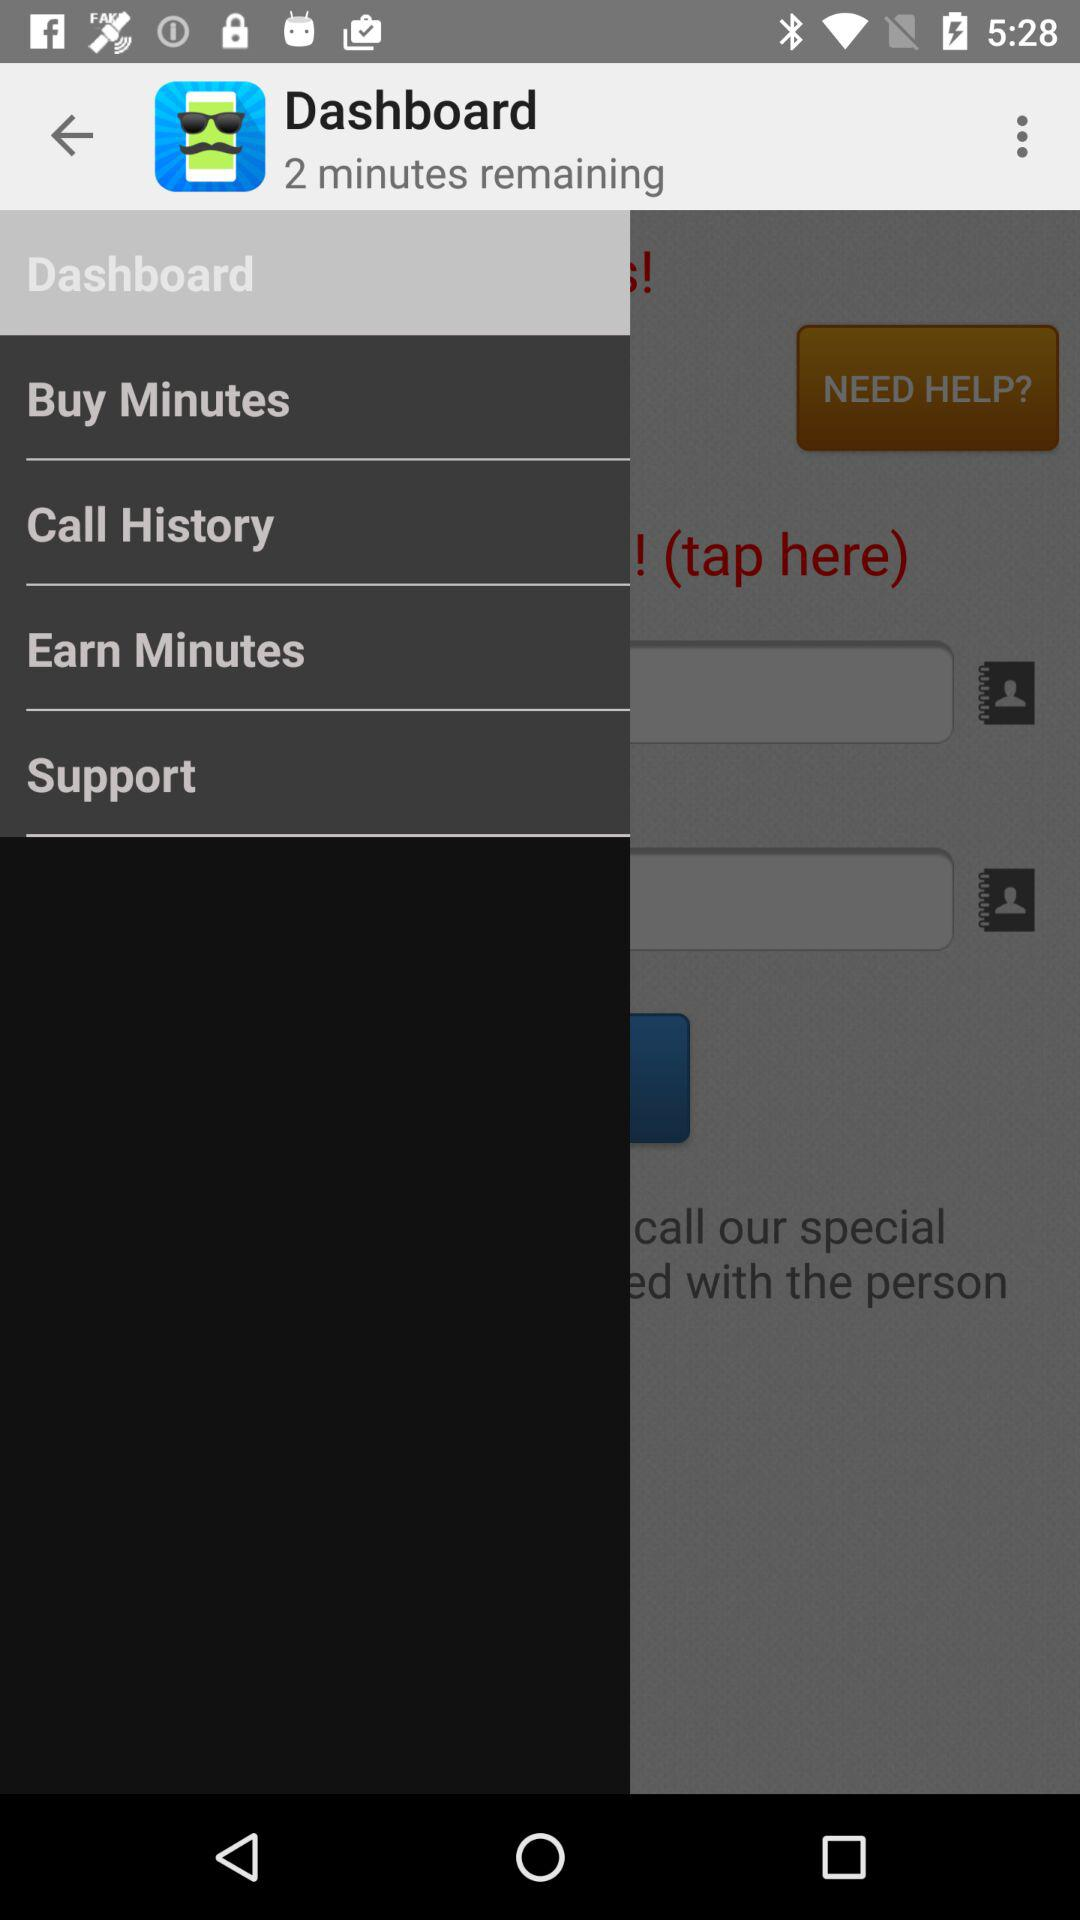What is the application name? The application name is "Dashboard". 